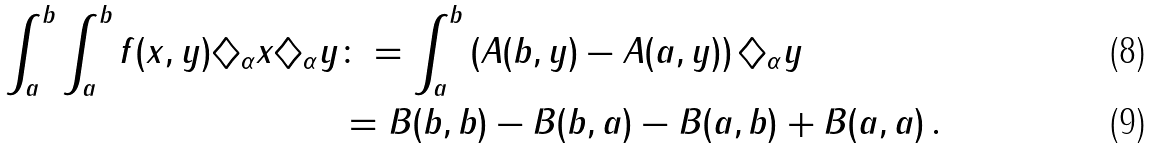<formula> <loc_0><loc_0><loc_500><loc_500>\int _ { a } ^ { b } \int _ { a } ^ { b } f ( x , y ) \diamondsuit _ { \alpha } x \diamondsuit _ { \alpha } y & \colon = \int _ { a } ^ { b } \left ( A ( b , y ) - A ( a , y ) \right ) \diamondsuit _ { \alpha } y \\ & = B ( b , b ) - B ( b , a ) - B ( a , b ) + B ( a , a ) \, .</formula> 